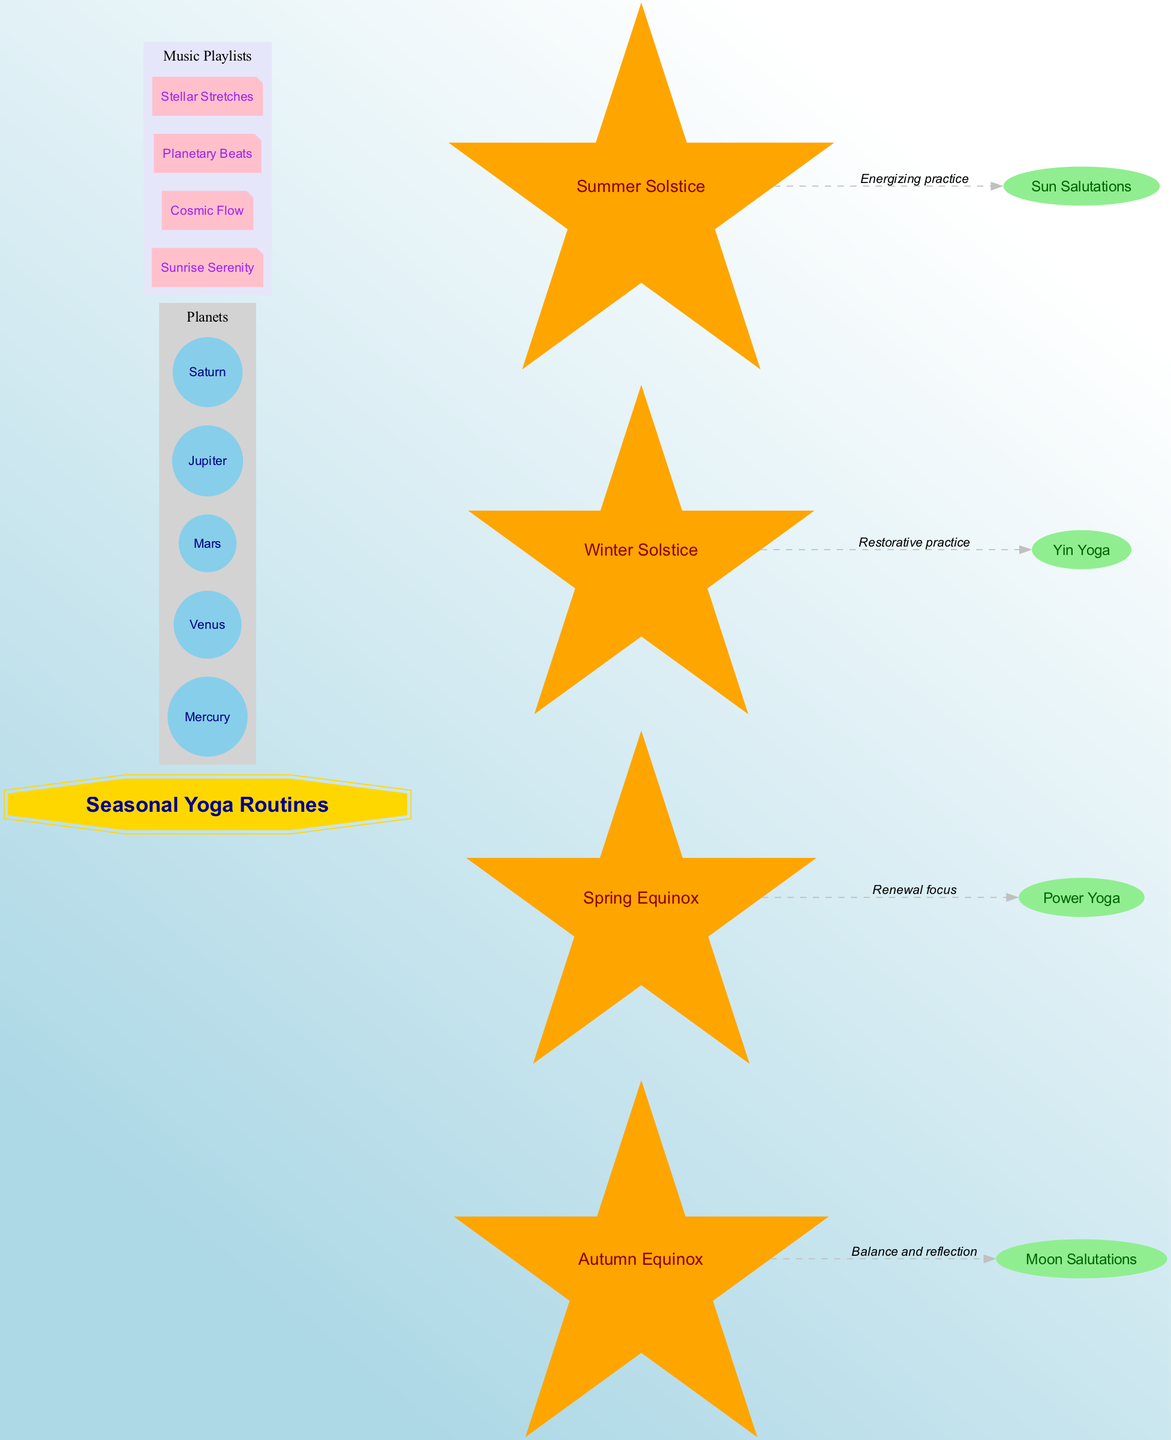What is the central element of the diagram? The diagram visually highlights "Seasonal Yoga Routines" in a prominent double-octagon shape at the center.
Answer: Seasonal Yoga Routines How many planets are depicted in the diagram? The diagram lists five different planets within a group labeled "Planets," which are Mercury, Venus, Mars, Jupiter, and Saturn.
Answer: 5 What yoga style is connected to the Spring Equinox? The connection from the Spring Equinox leads directly to "Power Yoga," which is labeled with "Renewal focus."
Answer: Power Yoga Which celestial event is associated with "Restorative practice"? According to the diagram, the Winter Solstice is the celestial event linked to the yoga style "Yin Yoga," indicated by the label "Restorative practice."
Answer: Winter Solstice What kind of music playlist is connected to Moon Salutations? The Autumn Equinox is associated with the yoga style "Moon Salutations," which represents balance and reflection in the context of the diagram.
Answer: Autumn Equinox Which yoga style corresponds with the Summer Solstice? The Summer Solstice connects to the yoga style "Sun Salutations," noted for being an energizing practice.
Answer: Sun Salutations Identify one planet shown in the diagram. Within the diagram, there are multiple planets listed, including Mercury, among others mentioned in the group of planets.
Answer: Mercury What color represents the music playlists in the diagram? The music playlists are depicted in a lavender color, highlighted as a unique subgraph in the diagram.
Answer: Lavender How many connections are made from celestial events to yoga styles? The diagram shows four distinct connections between celestial events and their respective yoga styles, illustrating seasonal links.
Answer: 4 